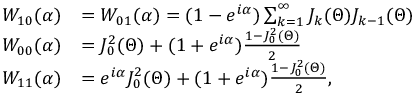Convert formula to latex. <formula><loc_0><loc_0><loc_500><loc_500>\begin{array} { r l } { W _ { 1 0 } ( \alpha ) } & { = W _ { 0 1 } ( \alpha ) = ( 1 - e ^ { i \alpha } ) \sum _ { k = 1 } ^ { \infty } J _ { k } ( \Theta ) J _ { k - 1 } ( \Theta ) } \\ { W _ { 0 0 } ( \alpha ) } & { = J _ { 0 } ^ { 2 } ( \Theta ) + ( 1 + e ^ { i \alpha } ) \frac { 1 - J _ { 0 } ^ { 2 } ( \Theta ) } { 2 } } \\ { W _ { 1 1 } ( \alpha ) } & { = e ^ { i \alpha } J _ { 0 } ^ { 2 } ( \Theta ) + ( 1 + e ^ { i \alpha } ) \frac { 1 - J _ { 0 } ^ { 2 } ( \Theta ) } { 2 } , } \end{array}</formula> 